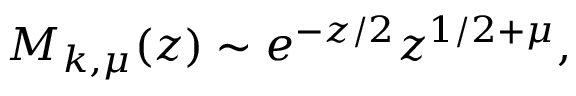Convert formula to latex. <formula><loc_0><loc_0><loc_500><loc_500>M _ { k , \mu } ( z ) \sim e ^ { - z / 2 } z ^ { 1 / 2 + \mu } ,</formula> 